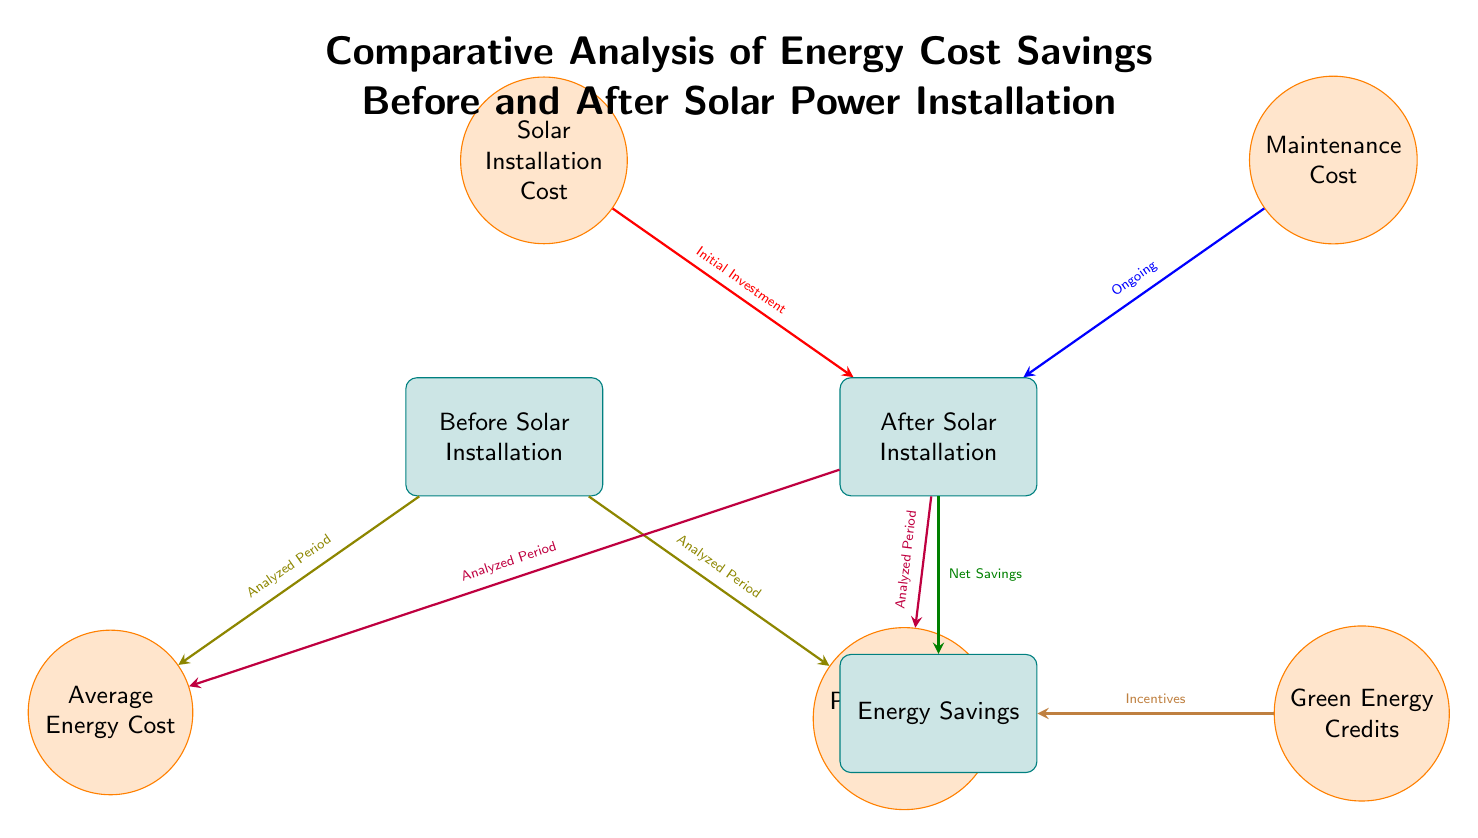What does the left box represent in the diagram? The left box labeled "Before Solar Installation" indicates the state of energy costs prior to the implementation of solar power in businesses.
Answer: Before Solar Installation What flows from the "Before Solar Installation" box to "Average Energy Cost"? The "Average Energy Cost" node receives an input arrow from the "Before Solar Installation" box, indicating the average energy costs during that period.
Answer: Analyzed Period How many main nodes are present in the "After Solar Installation" section? Within the "After Solar Installation" box, there are three significant nodes: "Solar Installation Cost," "Maintenance Cost," and "Energy Savings." Thus, there are three main nodes.
Answer: Three What indicates the financial impact of solar installation on energy savings? The arrow labeled "Net Savings" flowing from the "After Solar Installation" box to "Energy Savings" indicates the financial impact.
Answer: Net Savings What is the relationship between "Maintenance Cost" and "After Solar Installation"? The relationship is that the "Maintenance Cost" directly influences the "After Solar Installation" box, represented by an arrow, highlighting it as an ongoing expense post-installation.
Answer: Ongoing What do the circles symbolize in the diagram? The circles in the diagram represent specific costs or credits associated with energy and solar power, emphasizing important variables like costs and savings.
Answer: Specific costs or credits 